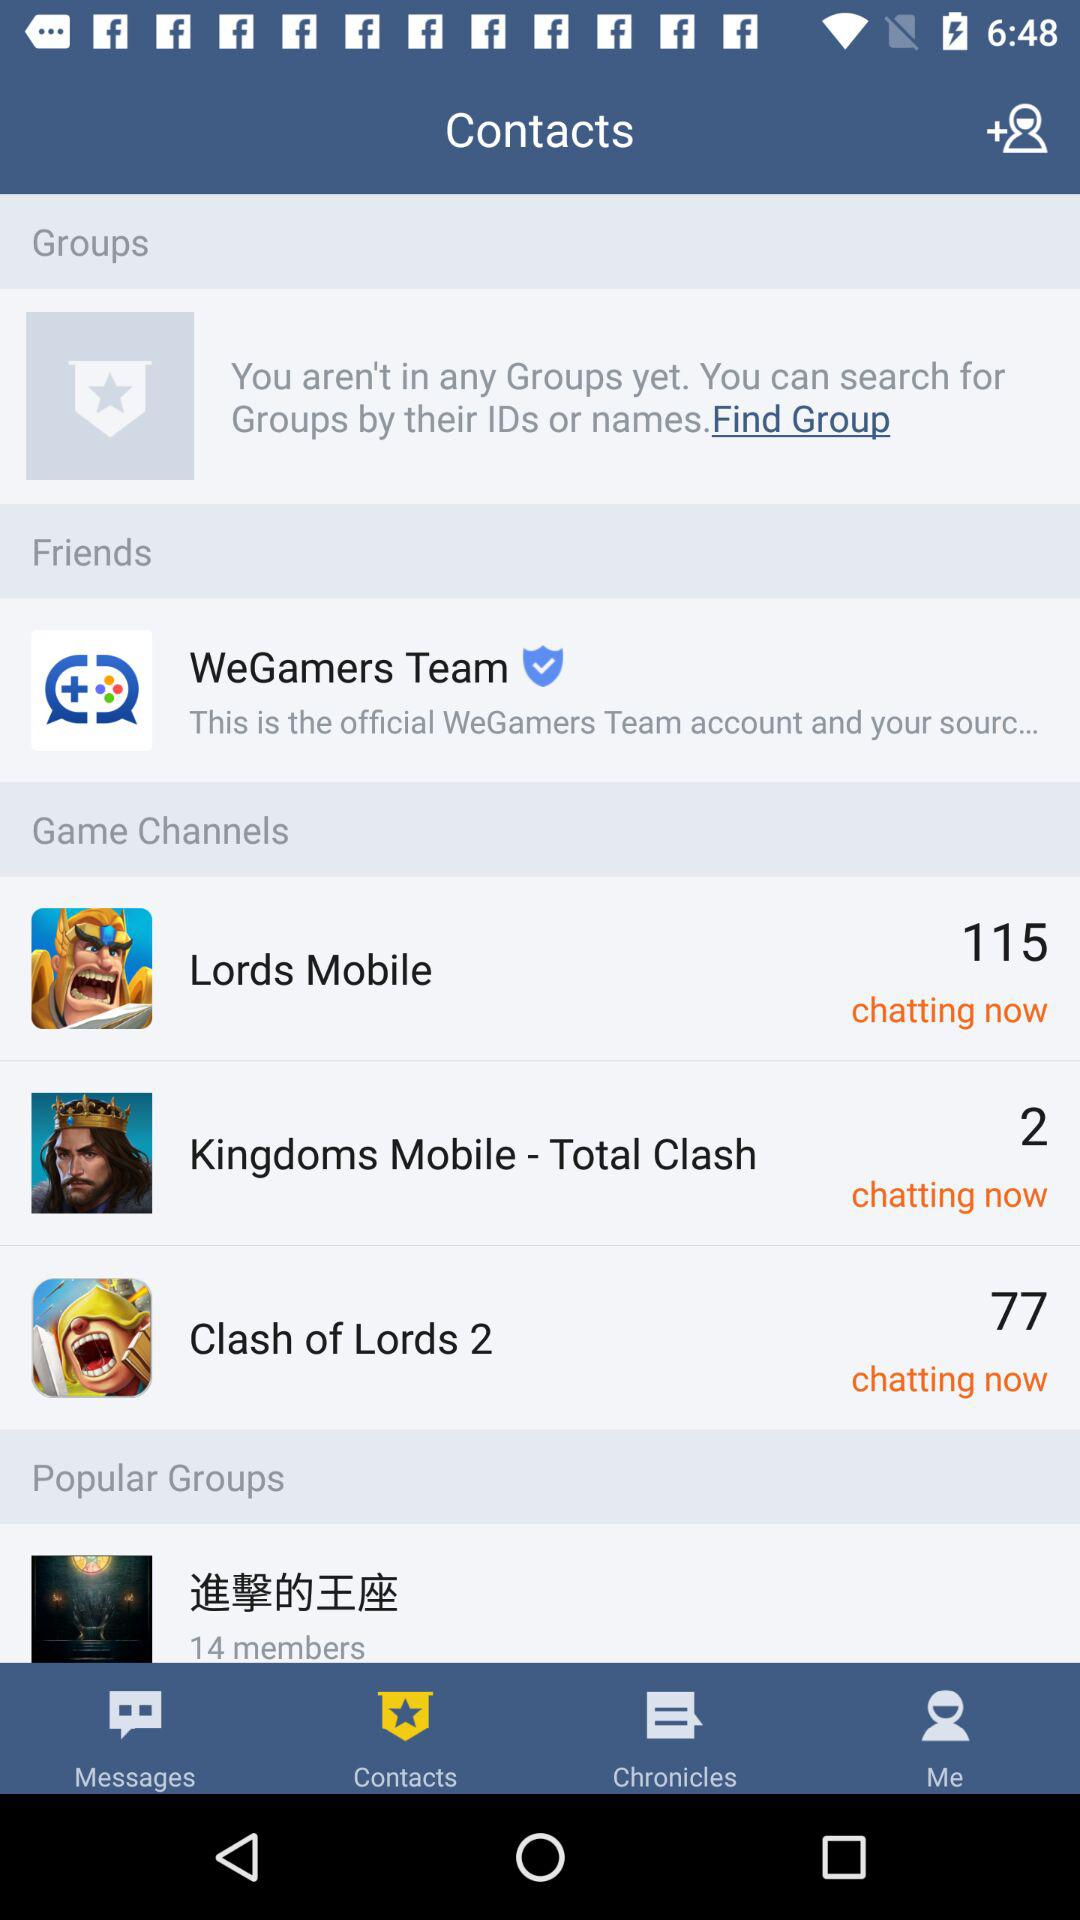How many more game channels are there than popular groups?
Answer the question using a single word or phrase. 2 